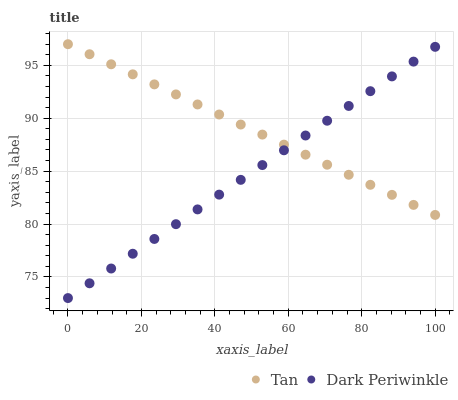Does Dark Periwinkle have the minimum area under the curve?
Answer yes or no. Yes. Does Tan have the maximum area under the curve?
Answer yes or no. Yes. Does Dark Periwinkle have the maximum area under the curve?
Answer yes or no. No. Is Dark Periwinkle the smoothest?
Answer yes or no. Yes. Is Tan the roughest?
Answer yes or no. Yes. Is Dark Periwinkle the roughest?
Answer yes or no. No. Does Dark Periwinkle have the lowest value?
Answer yes or no. Yes. Does Tan have the highest value?
Answer yes or no. Yes. Does Dark Periwinkle have the highest value?
Answer yes or no. No. Does Tan intersect Dark Periwinkle?
Answer yes or no. Yes. Is Tan less than Dark Periwinkle?
Answer yes or no. No. Is Tan greater than Dark Periwinkle?
Answer yes or no. No. 